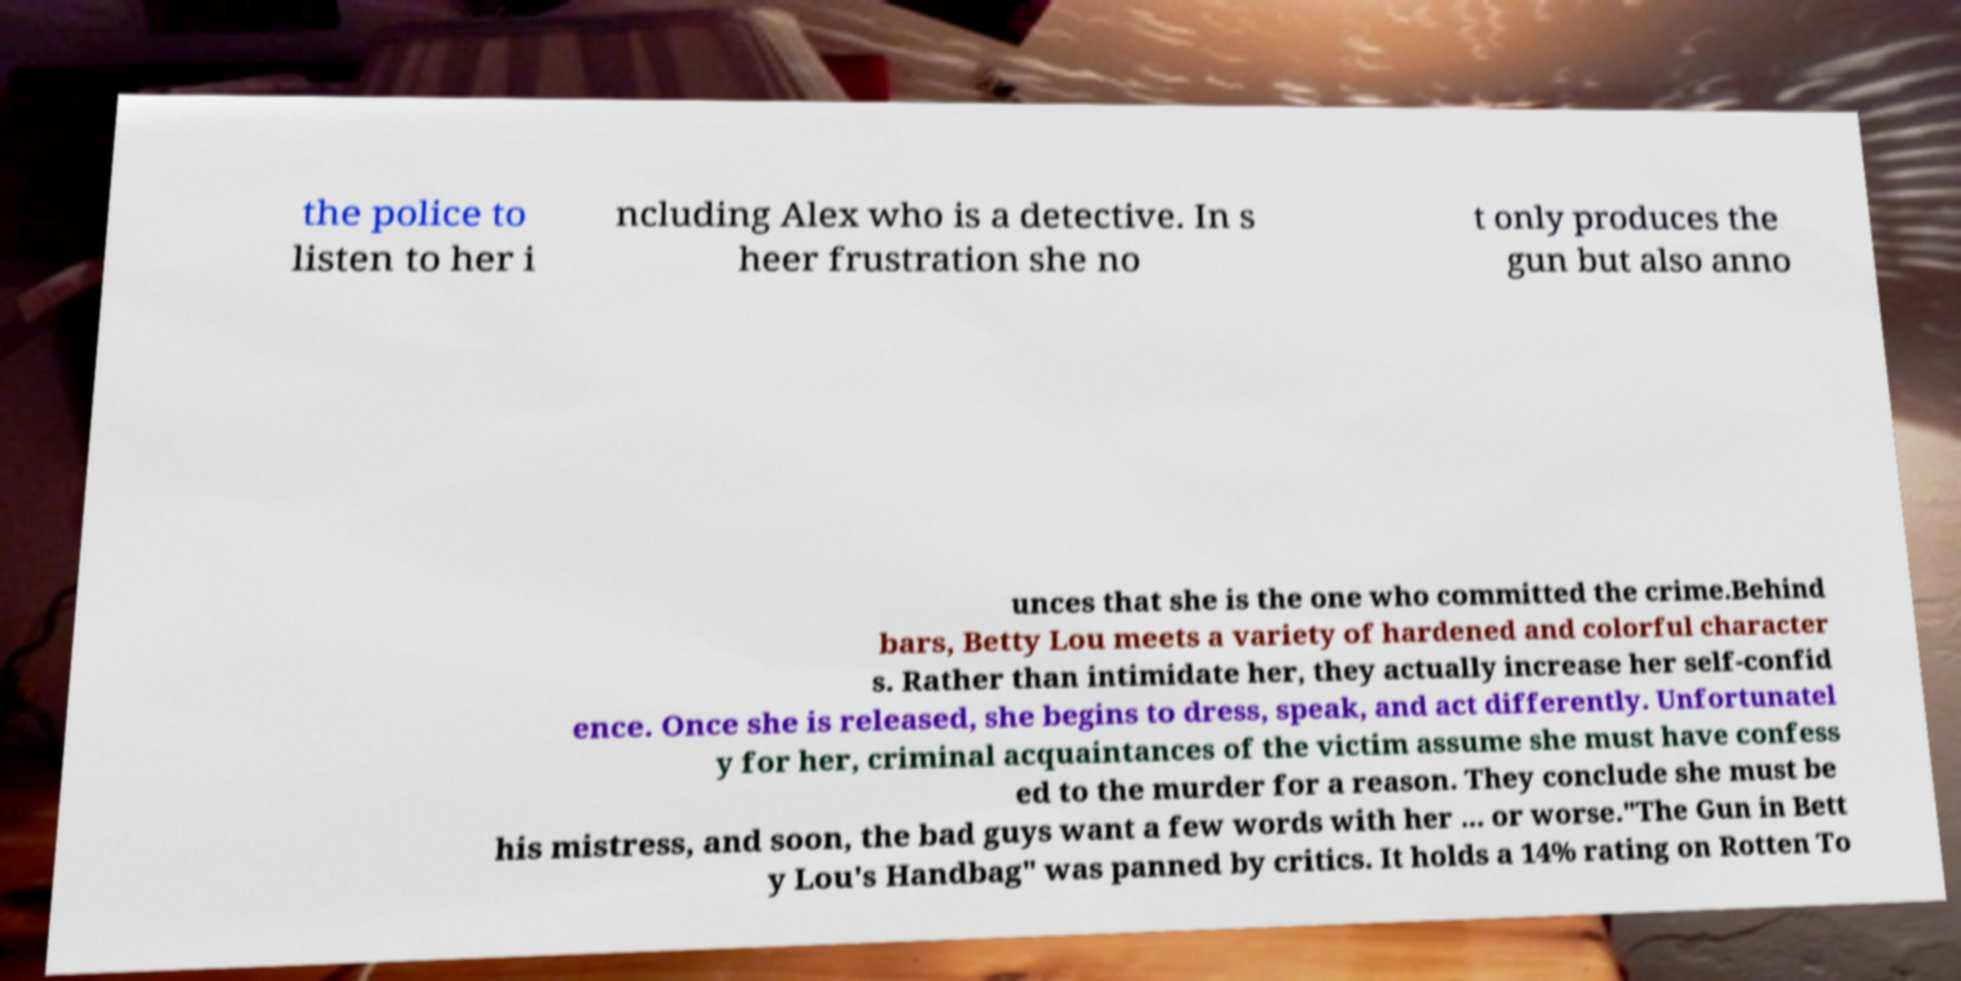Can you read and provide the text displayed in the image?This photo seems to have some interesting text. Can you extract and type it out for me? the police to listen to her i ncluding Alex who is a detective. In s heer frustration she no t only produces the gun but also anno unces that she is the one who committed the crime.Behind bars, Betty Lou meets a variety of hardened and colorful character s. Rather than intimidate her, they actually increase her self-confid ence. Once she is released, she begins to dress, speak, and act differently. Unfortunatel y for her, criminal acquaintances of the victim assume she must have confess ed to the murder for a reason. They conclude she must be his mistress, and soon, the bad guys want a few words with her ... or worse."The Gun in Bett y Lou's Handbag" was panned by critics. It holds a 14% rating on Rotten To 